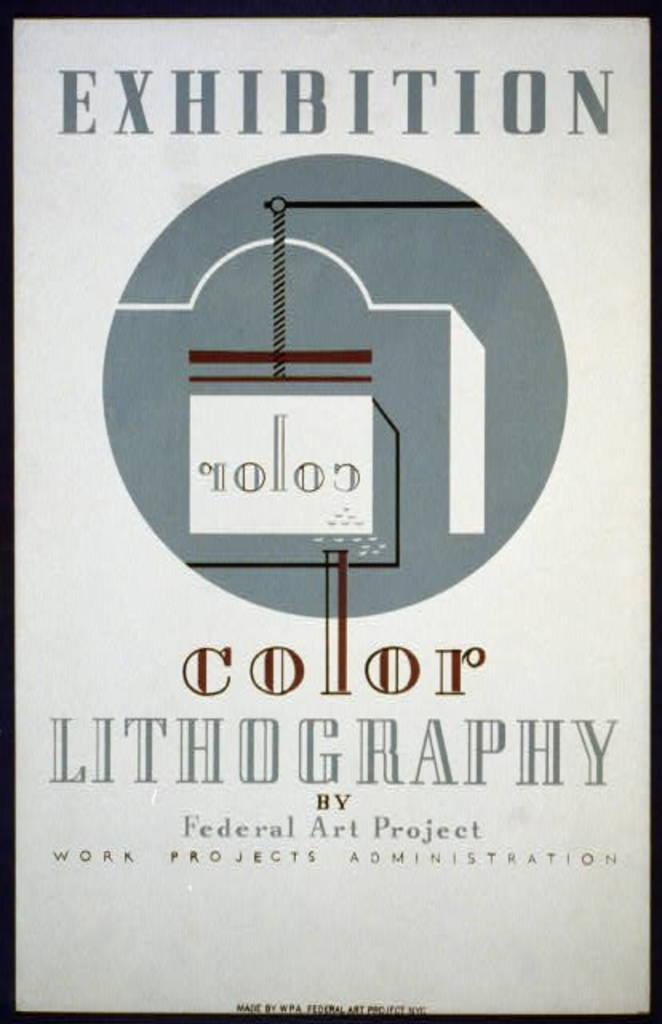<image>
Provide a brief description of the given image. An older looking copy of a color lithography page by Federal Art Project. 